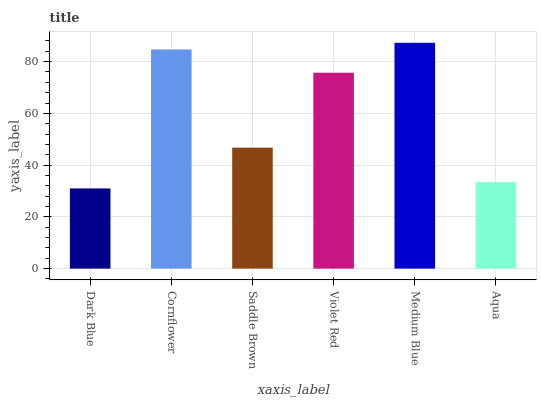Is Dark Blue the minimum?
Answer yes or no. Yes. Is Medium Blue the maximum?
Answer yes or no. Yes. Is Cornflower the minimum?
Answer yes or no. No. Is Cornflower the maximum?
Answer yes or no. No. Is Cornflower greater than Dark Blue?
Answer yes or no. Yes. Is Dark Blue less than Cornflower?
Answer yes or no. Yes. Is Dark Blue greater than Cornflower?
Answer yes or no. No. Is Cornflower less than Dark Blue?
Answer yes or no. No. Is Violet Red the high median?
Answer yes or no. Yes. Is Saddle Brown the low median?
Answer yes or no. Yes. Is Saddle Brown the high median?
Answer yes or no. No. Is Violet Red the low median?
Answer yes or no. No. 